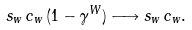<formula> <loc_0><loc_0><loc_500><loc_500>s _ { w } \, c _ { w } \, ( 1 - \gamma ^ { W } ) \longrightarrow s _ { w } \, c _ { w } .</formula> 